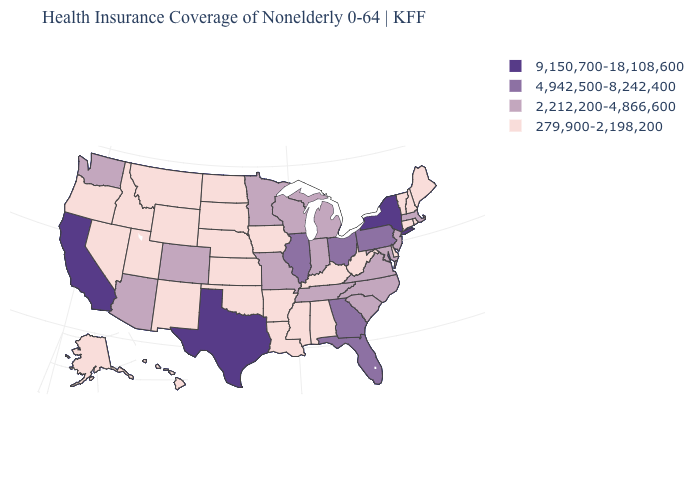Which states have the highest value in the USA?
Give a very brief answer. California, New York, Texas. What is the value of Louisiana?
Give a very brief answer. 279,900-2,198,200. Name the states that have a value in the range 279,900-2,198,200?
Write a very short answer. Alabama, Alaska, Arkansas, Connecticut, Delaware, Hawaii, Idaho, Iowa, Kansas, Kentucky, Louisiana, Maine, Mississippi, Montana, Nebraska, Nevada, New Hampshire, New Mexico, North Dakota, Oklahoma, Oregon, Rhode Island, South Dakota, Utah, Vermont, West Virginia, Wyoming. Does Hawaii have the lowest value in the USA?
Keep it brief. Yes. What is the lowest value in the USA?
Give a very brief answer. 279,900-2,198,200. What is the value of New Hampshire?
Answer briefly. 279,900-2,198,200. What is the value of Minnesota?
Concise answer only. 2,212,200-4,866,600. Name the states that have a value in the range 2,212,200-4,866,600?
Keep it brief. Arizona, Colorado, Indiana, Maryland, Massachusetts, Michigan, Minnesota, Missouri, New Jersey, North Carolina, South Carolina, Tennessee, Virginia, Washington, Wisconsin. Name the states that have a value in the range 279,900-2,198,200?
Concise answer only. Alabama, Alaska, Arkansas, Connecticut, Delaware, Hawaii, Idaho, Iowa, Kansas, Kentucky, Louisiana, Maine, Mississippi, Montana, Nebraska, Nevada, New Hampshire, New Mexico, North Dakota, Oklahoma, Oregon, Rhode Island, South Dakota, Utah, Vermont, West Virginia, Wyoming. What is the value of Massachusetts?
Keep it brief. 2,212,200-4,866,600. Does Nebraska have a lower value than Ohio?
Quick response, please. Yes. Name the states that have a value in the range 4,942,500-8,242,400?
Be succinct. Florida, Georgia, Illinois, Ohio, Pennsylvania. What is the value of New Jersey?
Quick response, please. 2,212,200-4,866,600. Which states have the lowest value in the USA?
Write a very short answer. Alabama, Alaska, Arkansas, Connecticut, Delaware, Hawaii, Idaho, Iowa, Kansas, Kentucky, Louisiana, Maine, Mississippi, Montana, Nebraska, Nevada, New Hampshire, New Mexico, North Dakota, Oklahoma, Oregon, Rhode Island, South Dakota, Utah, Vermont, West Virginia, Wyoming. What is the value of Colorado?
Keep it brief. 2,212,200-4,866,600. 